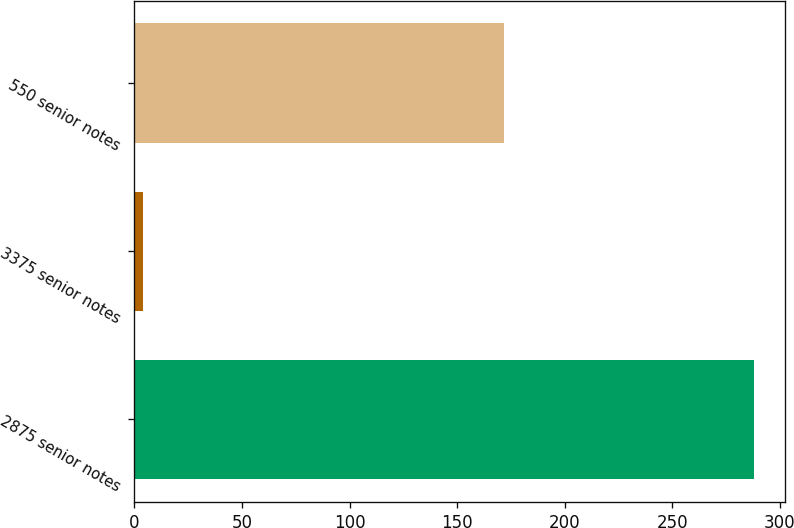Convert chart. <chart><loc_0><loc_0><loc_500><loc_500><bar_chart><fcel>2875 senior notes<fcel>3375 senior notes<fcel>550 senior notes<nl><fcel>288<fcel>4<fcel>172<nl></chart> 